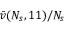Convert formula to latex. <formula><loc_0><loc_0><loc_500><loc_500>\bar { v } ( N _ { s } , 1 1 ) / N _ { s }</formula> 